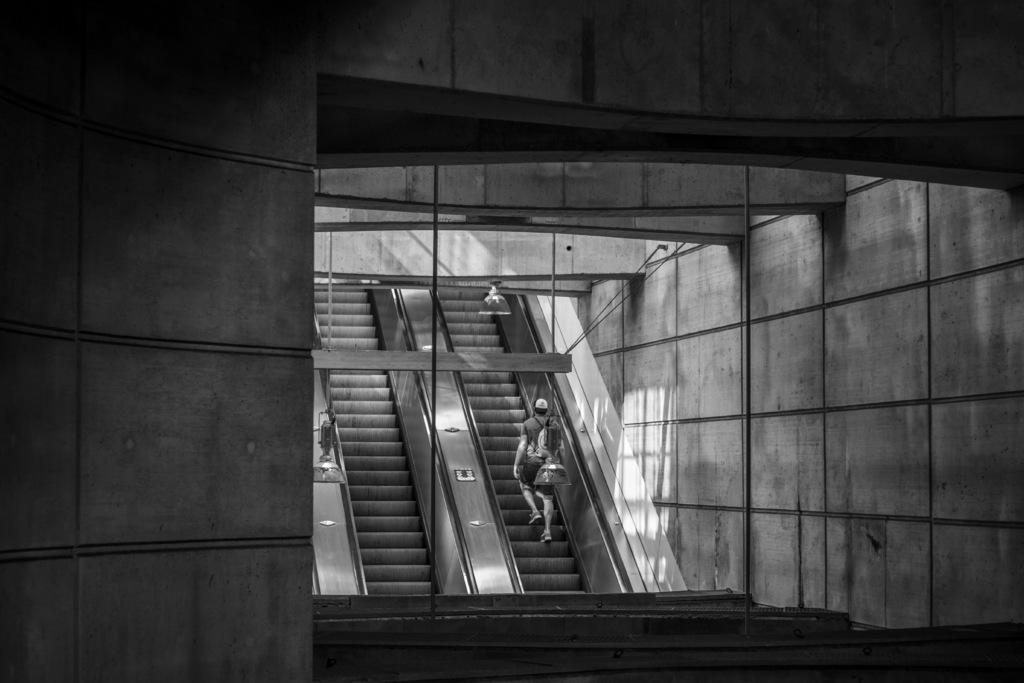What is the color scheme of the image? The image is black and white. What is the person in the image doing? The person is standing on an escalator. Are there any other escalators visible in the image? Yes, there is another escalator beside the person. What can be seen in the background of the image? Lights and walls are visible in the image. What other objects can be seen in the image? Other objects are present in the image, but their specific details are not mentioned in the provided facts. Can you tell me how many robins are perched on the chess pieces in the image? There are no chess pieces or robins present in the image. What type of hammer is being used by the person on the escalator in the image? There is no hammer visible in the image; the person is simply standing on the escalator. 